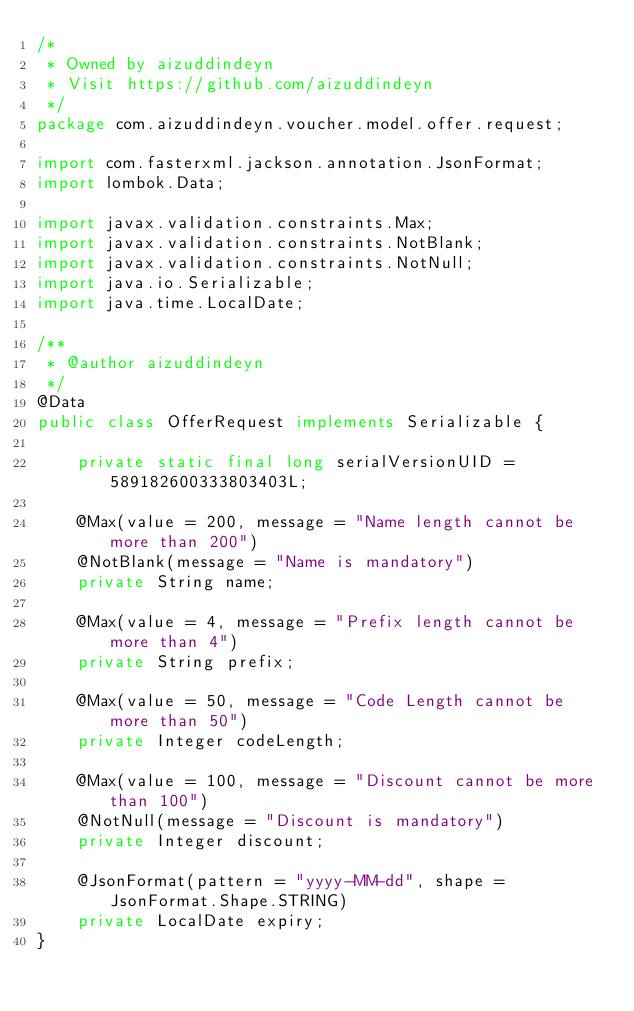<code> <loc_0><loc_0><loc_500><loc_500><_Java_>/*
 * Owned by aizuddindeyn
 * Visit https://github.com/aizuddindeyn
 */
package com.aizuddindeyn.voucher.model.offer.request;

import com.fasterxml.jackson.annotation.JsonFormat;
import lombok.Data;

import javax.validation.constraints.Max;
import javax.validation.constraints.NotBlank;
import javax.validation.constraints.NotNull;
import java.io.Serializable;
import java.time.LocalDate;

/**
 * @author aizuddindeyn
 */
@Data
public class OfferRequest implements Serializable {

    private static final long serialVersionUID = 589182600333803403L;

    @Max(value = 200, message = "Name length cannot be more than 200")
    @NotBlank(message = "Name is mandatory")
    private String name;

    @Max(value = 4, message = "Prefix length cannot be more than 4")
    private String prefix;

    @Max(value = 50, message = "Code Length cannot be more than 50")
    private Integer codeLength;

    @Max(value = 100, message = "Discount cannot be more than 100")
    @NotNull(message = "Discount is mandatory")
    private Integer discount;

    @JsonFormat(pattern = "yyyy-MM-dd", shape = JsonFormat.Shape.STRING)
    private LocalDate expiry;
}
</code> 